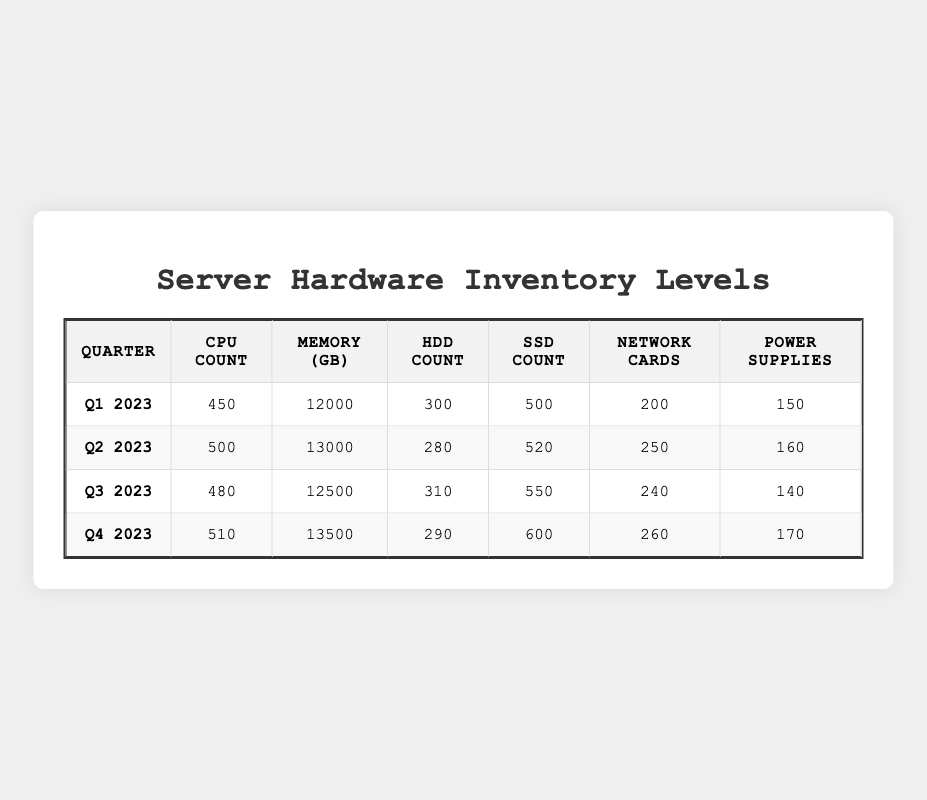What was the total number of CPUs available in Q2 2023? In Q2 2023, the table shows a CPU count of 500.
Answer: 500 Which quarter had the highest inventory of SSDs? Observing the SSD counts across the quarters, Q4 2023 has the highest count with 600 SSDs.
Answer: Q4 2023 What is the difference in memory (in GB) between Q1 2023 and Q3 2023? For Q1 2023, the memory is 12000 GB, and for Q3 2023, it is 12500 GB. The difference is 12500 - 12000 = 500 GB.
Answer: 500 GB In which quarter was the least number of HDDs in stock, and what was that number? Looking at the HDD counts, Q2 2023 has the least with 280 HDDs.
Answer: Q2 2023, 280 HDDs What is the average number of power supplies across all quarters? To calculate the average, sum the power supplies: 150 + 160 + 140 + 170 = 620, and divide it by the number of quarters, which is 4. So, 620/4 = 155.
Answer: 155 Was there an increase or decrease in the number of network cards from Q1 2023 to Q4 2023? In Q1 2023, there were 200 network cards, and in Q4 2023, there are 260 network cards. Since 260 is greater than 200, it indicates an increase.
Answer: Increase How much total storage (in GB) across HDDs and SSDs was available in Q3 2023? In Q3 2023, there are 310 HDDs and 550 SSDs. The total count of storage devices is thus 310 + 550 = 860.
Answer: 860 Which quarter saw an increase in CPU count compared to the previous quarter? Comparing the CPU counts, Q2 2023 (500) is an increase over Q1 2023 (450), Q4 2023 (510) is an increase over Q3 2023 (480). Thus Q2 and Q4 both saw increases.
Answer: Q2 and Q4 What is the total count of hardware components (CPUs, Memory in GB, HDDs, SSDs, Network Cards, Power Supplies) in Q1 2023? Summing the inventory in Q1 2023: 450 + 12000 + 300 + 500 + 200 + 150 = 13900.
Answer: 13900 Is the memory inventory in Q4 2023 greater than the combined total of HDD and SSD inventories in that same quarter? In Q4 2023, the memory is 13500 GB, and the total of HDDs and SSDs is 290 + 600 = 890. Since 13500 is greater than 890, the statement is true.
Answer: Yes 